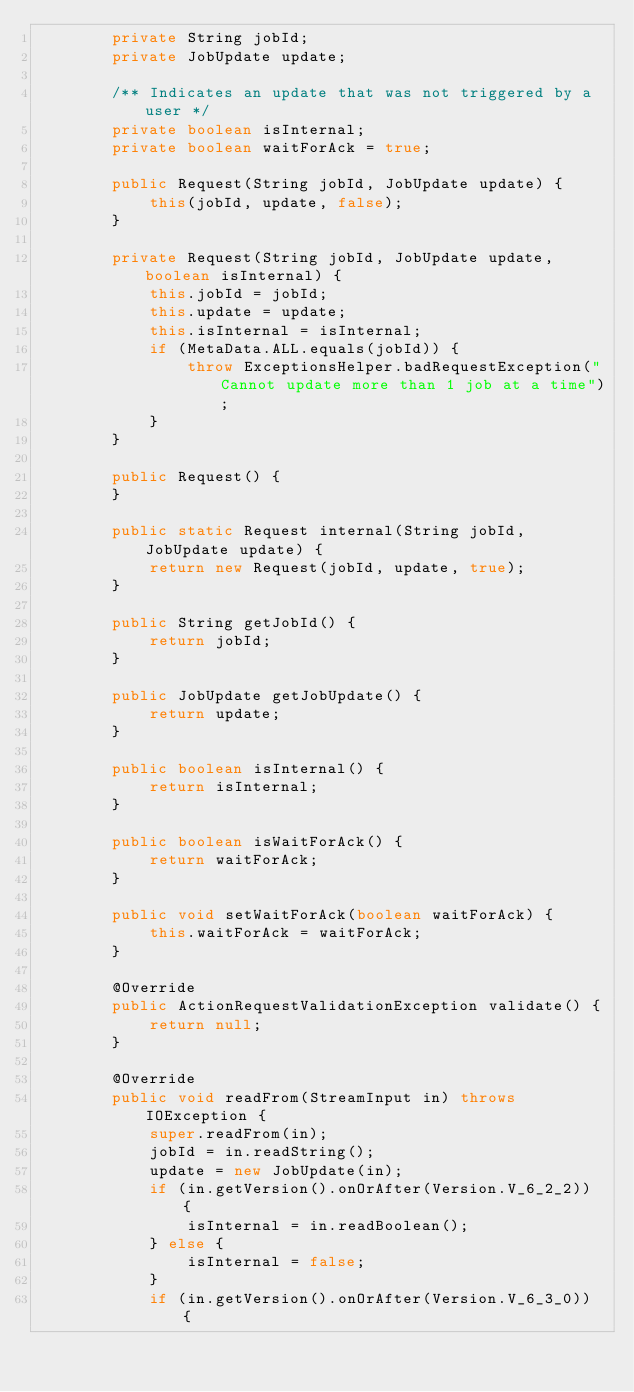Convert code to text. <code><loc_0><loc_0><loc_500><loc_500><_Java_>        private String jobId;
        private JobUpdate update;

        /** Indicates an update that was not triggered by a user */
        private boolean isInternal;
        private boolean waitForAck = true;

        public Request(String jobId, JobUpdate update) {
            this(jobId, update, false);
        }

        private Request(String jobId, JobUpdate update, boolean isInternal) {
            this.jobId = jobId;
            this.update = update;
            this.isInternal = isInternal;
            if (MetaData.ALL.equals(jobId)) {
                throw ExceptionsHelper.badRequestException("Cannot update more than 1 job at a time");
            }
        }

        public Request() {
        }

        public static Request internal(String jobId, JobUpdate update) {
            return new Request(jobId, update, true);
        }

        public String getJobId() {
            return jobId;
        }

        public JobUpdate getJobUpdate() {
            return update;
        }

        public boolean isInternal() {
            return isInternal;
        }

        public boolean isWaitForAck() {
            return waitForAck;
        }

        public void setWaitForAck(boolean waitForAck) {
            this.waitForAck = waitForAck;
        }

        @Override
        public ActionRequestValidationException validate() {
            return null;
        }

        @Override
        public void readFrom(StreamInput in) throws IOException {
            super.readFrom(in);
            jobId = in.readString();
            update = new JobUpdate(in);
            if (in.getVersion().onOrAfter(Version.V_6_2_2)) {
                isInternal = in.readBoolean();
            } else {
                isInternal = false;
            }
            if (in.getVersion().onOrAfter(Version.V_6_3_0)) {</code> 